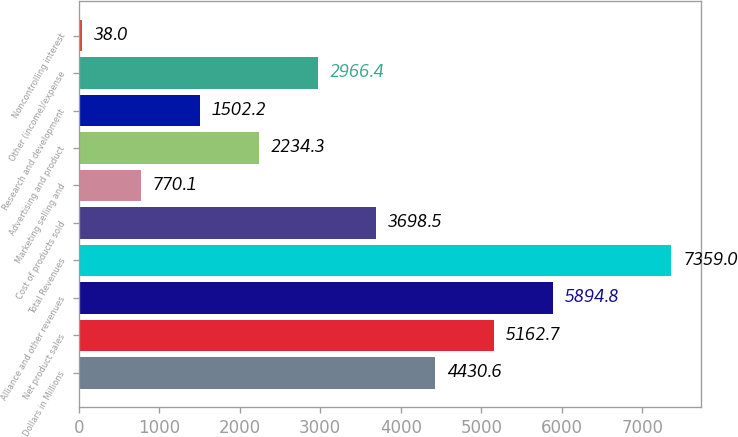<chart> <loc_0><loc_0><loc_500><loc_500><bar_chart><fcel>Dollars in Millions<fcel>Net product sales<fcel>Alliance and other revenues<fcel>Total Revenues<fcel>Cost of products sold<fcel>Marketing selling and<fcel>Advertising and product<fcel>Research and development<fcel>Other (income)/expense<fcel>Noncontrolling interest<nl><fcel>4430.6<fcel>5162.7<fcel>5894.8<fcel>7359<fcel>3698.5<fcel>770.1<fcel>2234.3<fcel>1502.2<fcel>2966.4<fcel>38<nl></chart> 